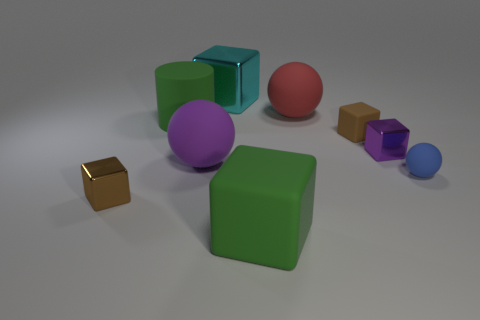There is a purple object behind the big purple matte sphere; what is its size? The object in question appears to be a small purple cube situated behind the large purple matte sphere. Despite its relative size, the cube's well-defined edges and solid color make it a notable element in the composition. 